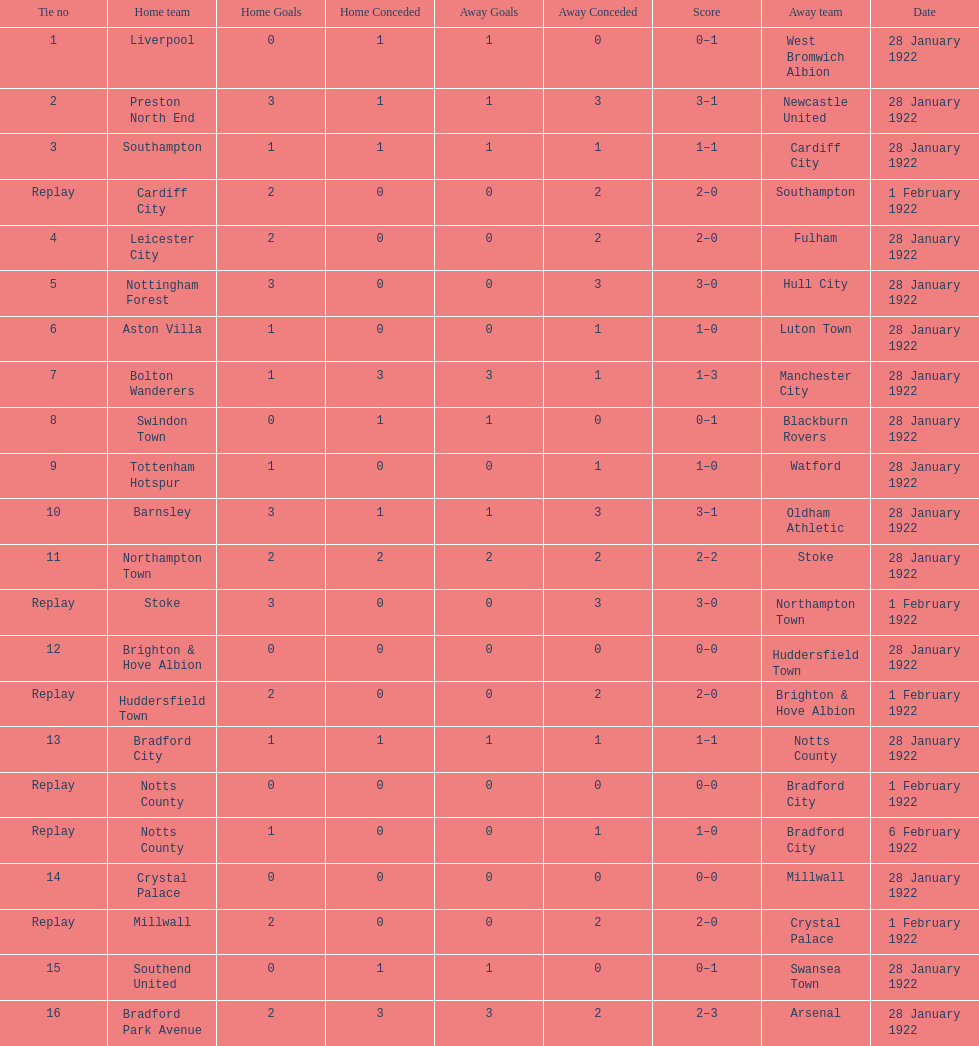How many games had no points scored? 3. 